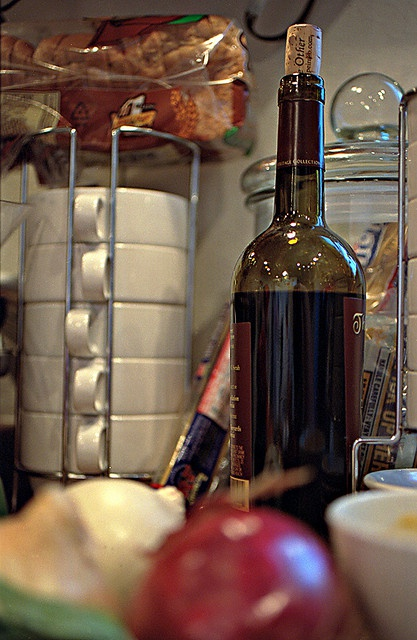Describe the objects in this image and their specific colors. I can see bottle in black, maroon, olive, and gray tones, apple in black, maroon, and brown tones, cup in black, tan, and gray tones, bowl in black, gray, darkgray, and tan tones, and cup in black, tan, and gray tones in this image. 